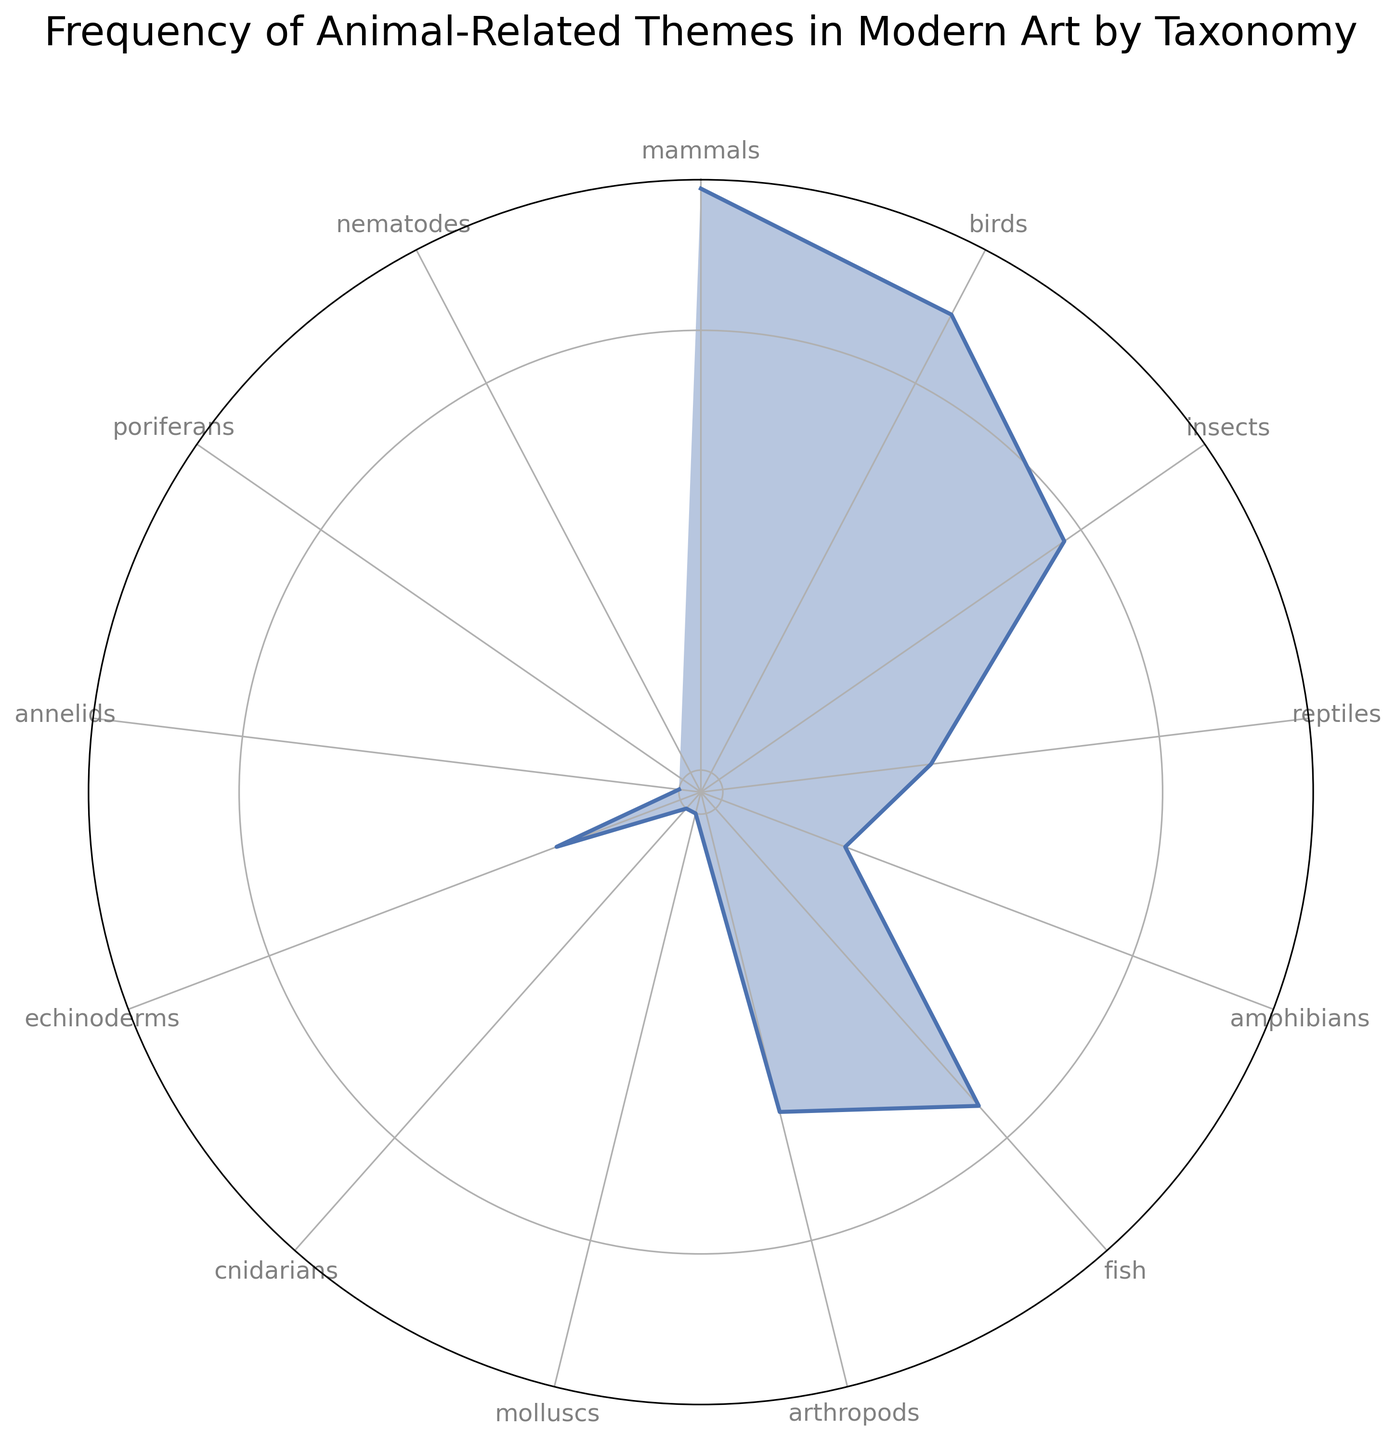Which group has the highest frequency? The group with the longest radius or highest peak in the plot represents the highest frequency. The longest radius corresponds to "mammals," which has a frequency of 21.
Answer: mammals Which taxonomies have a frequency of zero? In the plot, zero frequencies would be represented by a point at the center of the chart. The taxonomies with zero frequency are "poriferans" and "nematodes."
Answer: poriferans, nematodes What is the total frequency of the animal-related themes? To find the total frequency, sum all the values listed: 21 (mammals) + 15 (birds) + 9 (insects) + 3 (reptiles) + 2 (amphibians) + 8 (fish) + 5 (arthropods) + 1 (molluscs) + 1 (cnidarians) + 2 (echinoderms) + 1 (annelids) = 68.
Answer: 68 How does the frequency of bird-related themes compare to fish-related themes? The frequencies of "birds" and "fish" can be directly compared by looking at their corresponding radii. "Birds" has a frequency of 15, whereas "fish" has a frequency of 8. Since 15 is greater than 8, bird-related themes are more frequent.
Answer: Birds > Fish Which animal taxonomies have a frequency less than 3? By locating the taxonomies with their corresponding frequencies, those with values less than 3 are identified: "amphibians" (2), "molluscs" (1), "cnidarians" (1), "annelids" (1), "poriferans" (0), and "nematodes" (0).
Answer: Amphibians, Molluscs, Cnidarians, Annelids, Poriferans, Nematodes What is the average frequency of animal-related themes excluding taxonomies with zero frequency? Sum the frequencies excluding zero-value taxonomies and divide by the number of non-zero taxonomies (11): (21 + 15 + 9 + 3 + 2 + 8 + 5 + 1 + 1 + 2 + 1) / 11 = 68 / 11 ≈ 6.18.
Answer: 6.18 Which taxonomy has a frequency equal to the smallest non-zero frequency in the plot? The smallest non-zero frequency is 1. By identifying the taxonomy with this frequency, we find "molluscs," "cnidarians," and "annelids," each with a frequency of 1.
Answer: Molluscs, Cnidarians, Annelids Considering the frequencies provided, what is the median frequency value? Arrange the frequencies in ascending order: 0, 0, 1, 1, 1, 2, 2, 3, 5, 8, 9, 15, 21. The middle value (7th in order) is 2.
Answer: 2 